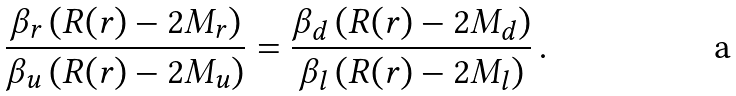Convert formula to latex. <formula><loc_0><loc_0><loc_500><loc_500>\frac { { \beta } _ { r } \left ( R ( { r } ) - 2 M _ { r } \right ) } { { \beta } _ { u } \left ( R ( { r } ) - 2 M _ { u } \right ) } = \frac { { \beta } _ { d } \left ( R ( { r } ) - 2 M _ { d } \right ) } { { \beta } _ { l } \left ( R ( { r } ) - 2 M _ { l } \right ) } \, .</formula> 